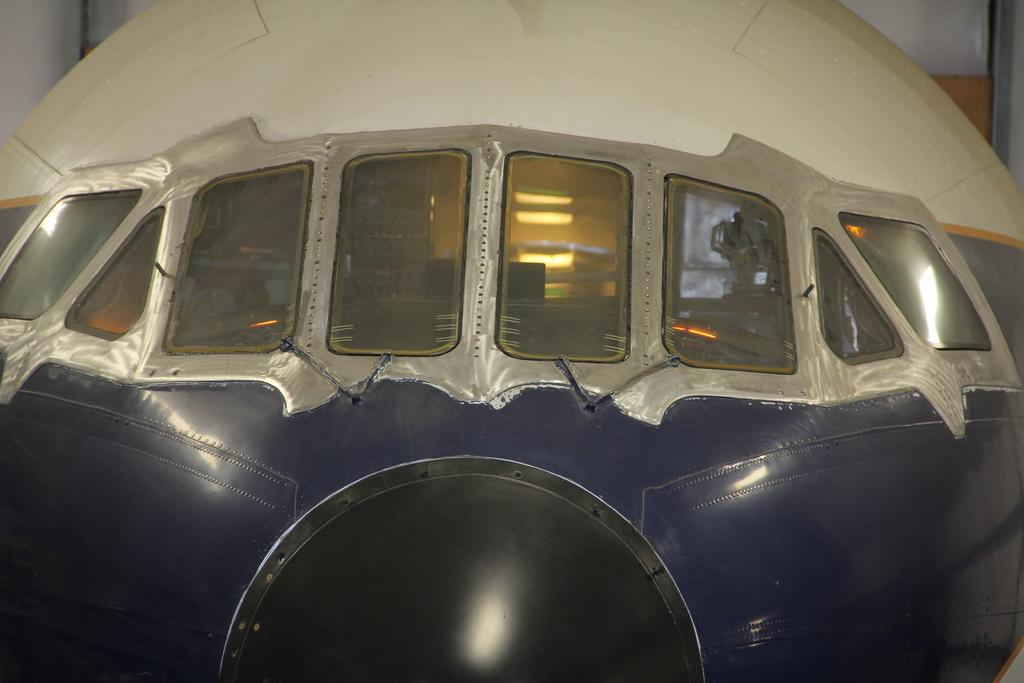What is the main subject of the image? The main subject of the image is a vehicle. What specific features can be observed on the vehicle? The vehicle has windows. What can be seen in the background of the image? There is a wall visible in the background of the image. Can you describe the setting where the image might have been taken? The image may have been taken in a hall. How many wristwatches can be seen on the vehicle in the image? There are no wristwatches visible on the vehicle in the image. Is there a squirrel sitting on the hood of the vehicle in the image? There is no squirrel present in the image. 